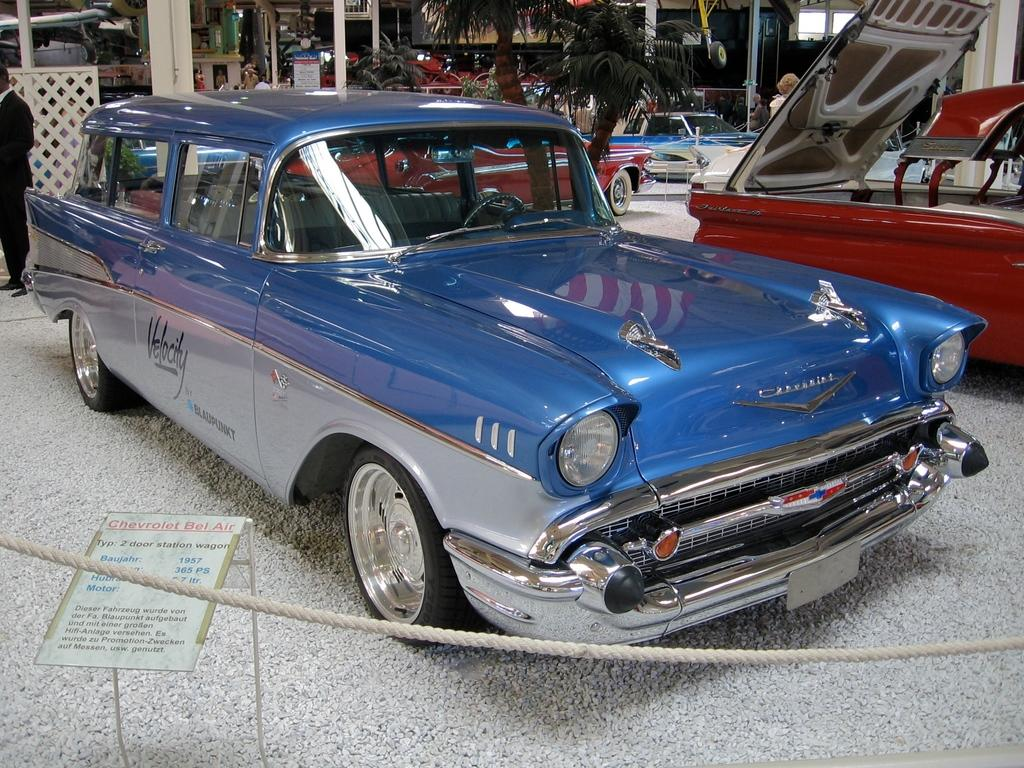What types of objects are present in the image? There are vehicles in the image. What type of natural elements can be seen in the image? There are trees in the image. What living beings are visible in the image? There are people in the image. Can you tell me how many geese are depicted in the amusement area in the image? There is no amusement area or geese present in the image. Are there any visitors visible in the image? The provided facts do not mention any visitors, so we cannot determine if there are any visitors in the image. 